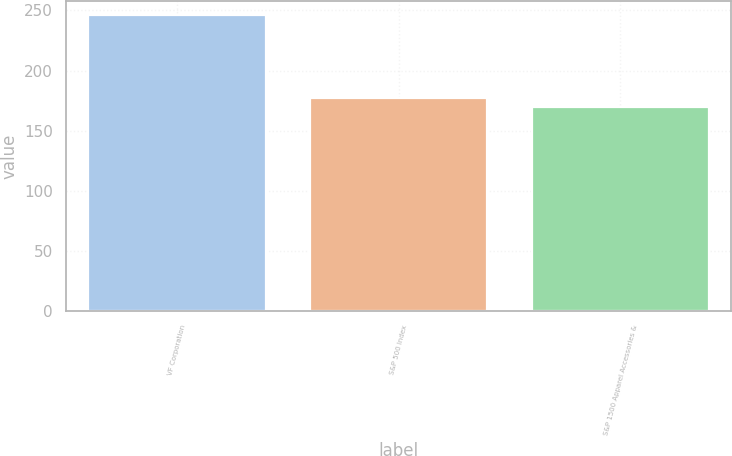<chart> <loc_0><loc_0><loc_500><loc_500><bar_chart><fcel>VF Corporation<fcel>S&P 500 Index<fcel>S&P 1500 Apparel Accessories &<nl><fcel>245.8<fcel>177.34<fcel>169.73<nl></chart> 